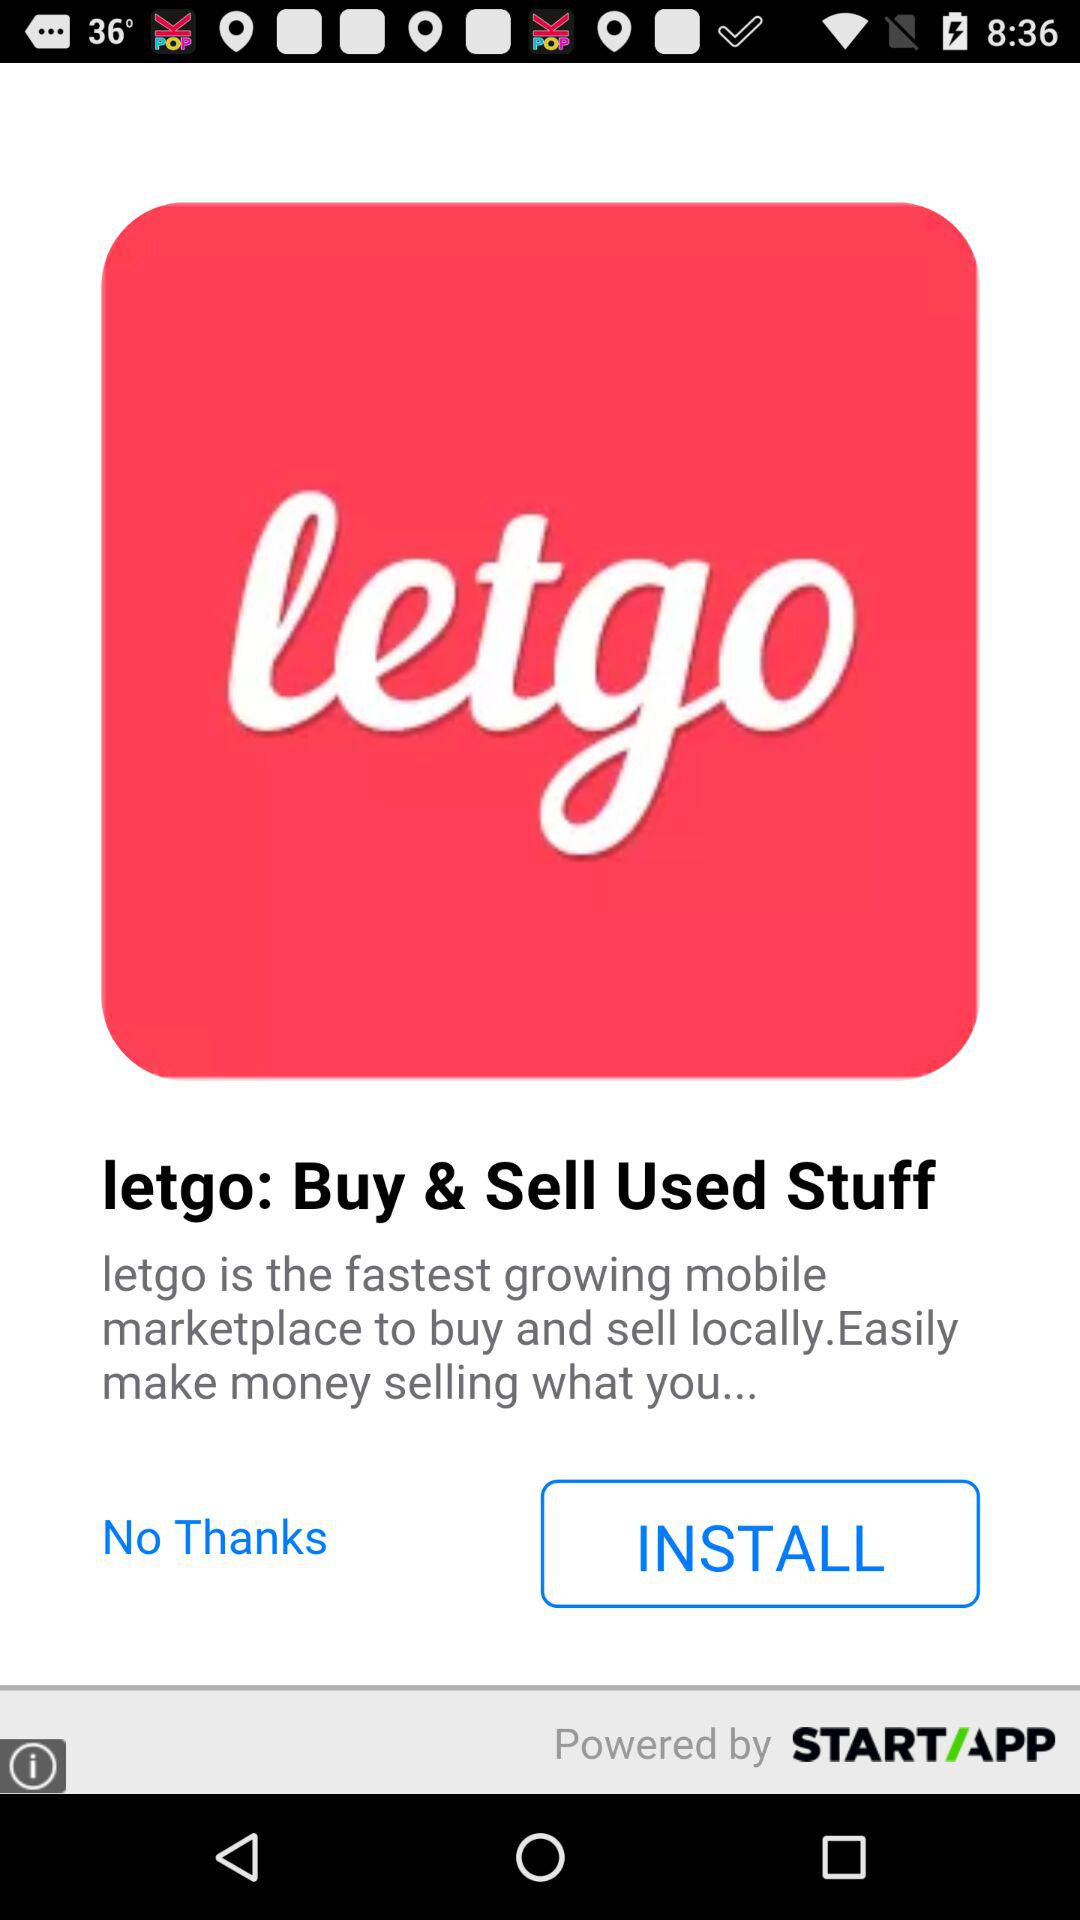When was "letgo" established as an application?
When the provided information is insufficient, respond with <no answer>. <no answer> 